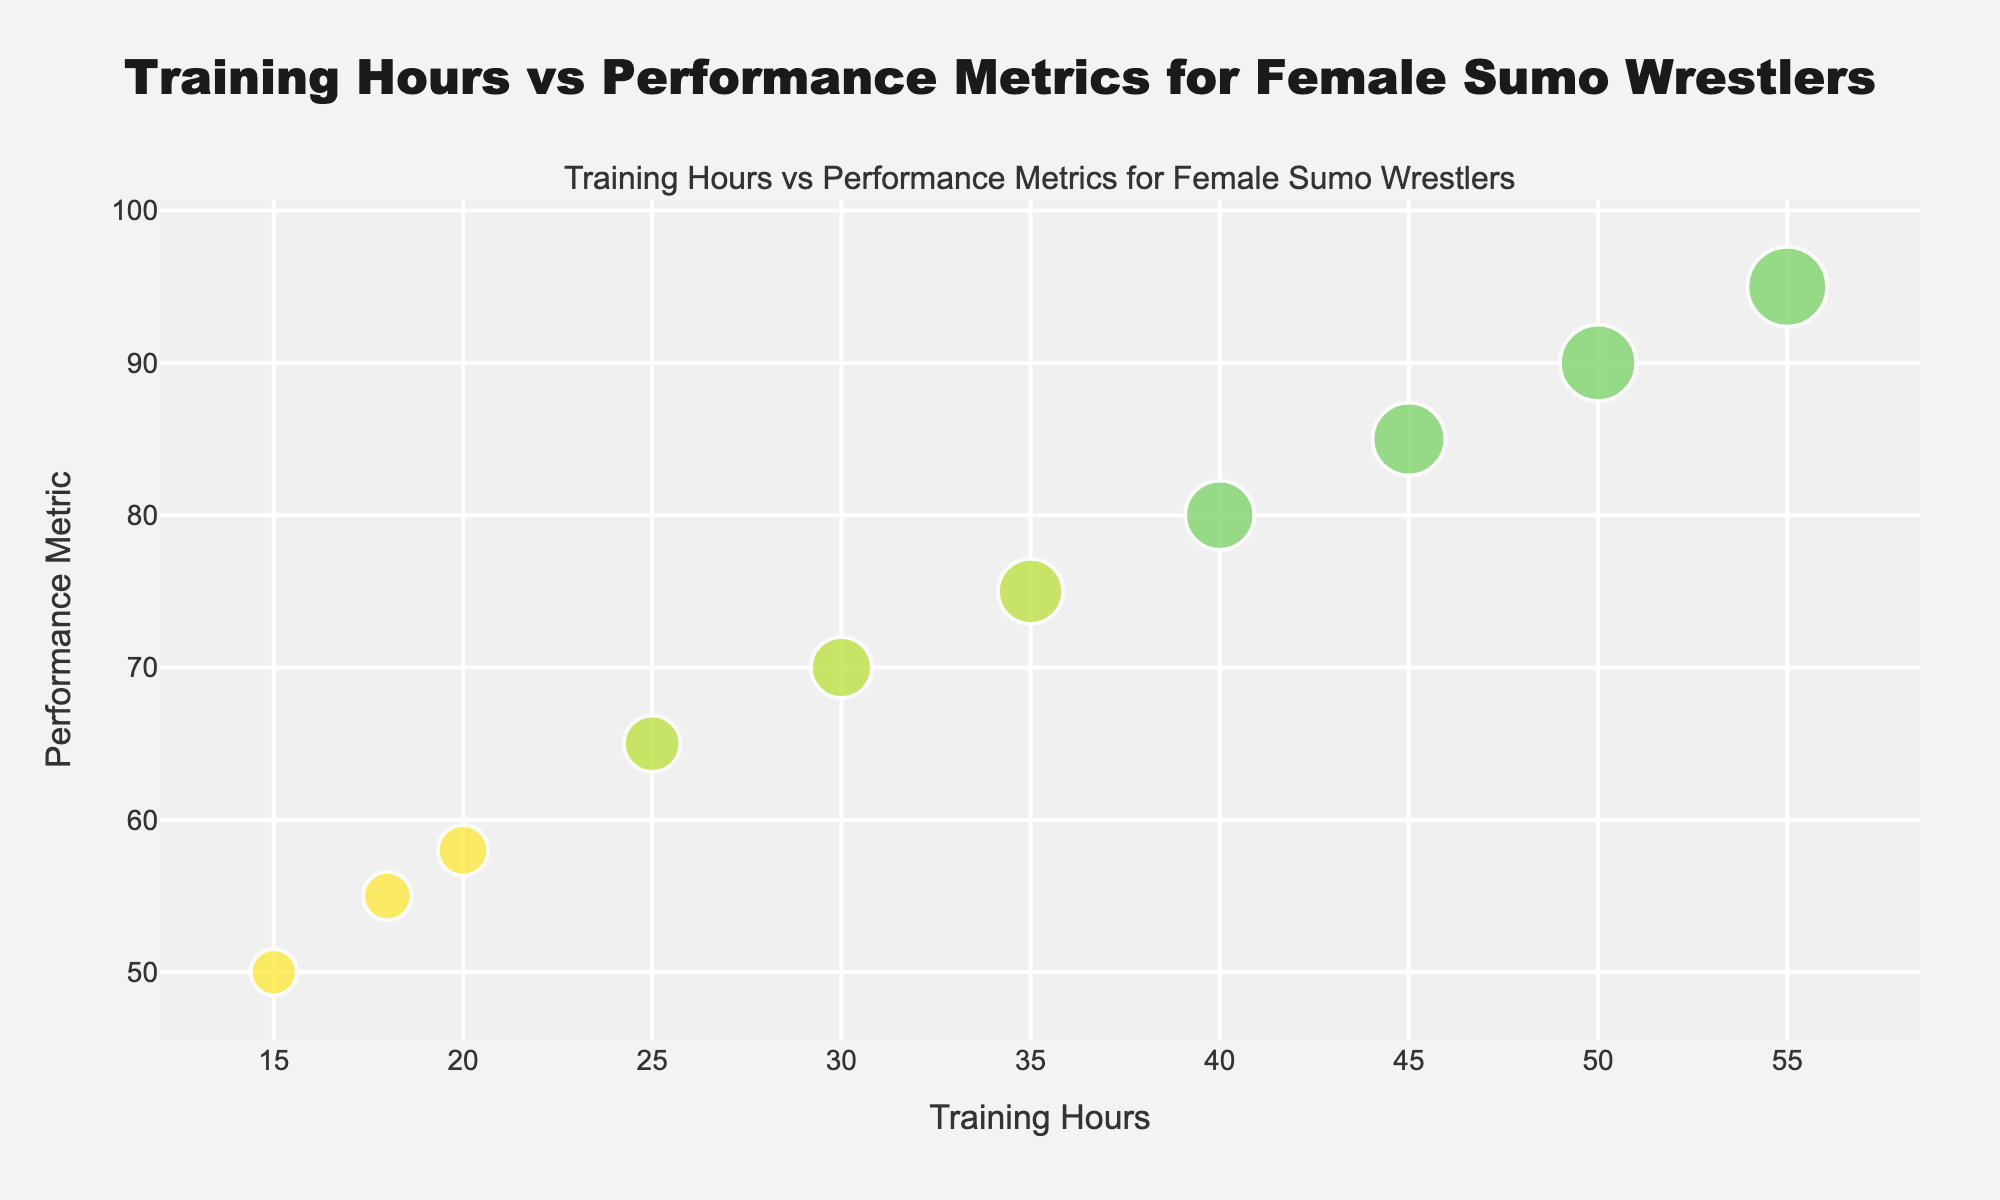What is the title of the figure? The title of the figure is displayed right at the top of the plot.
Answer: Training Hours vs Performance Metrics for Female Sumo Wrestlers What are the x-axis and y-axis labels? The x-axis and y-axis labels are located at the bottom (x-axis) and left (y-axis) sides of the plot respectively.
Answer: Training Hours (x-axis), Performance Metric (y-axis) How many data points are there in the plot? Upon visual inspection, we can count the bubbles in the figure.
Answer: 10 What does the color of the bubbles represent? The color of the bubbles is used to distinguish the experience levels of the female sumo wrestlers.
Answer: Experience Level Which wrestler has the highest performance metric? To find the wrestler with the highest performance metric, locate the highest point on the y-axis and check the corresponding wrestler's name displayed in the hover text.
Answer: Tomoko Who has the largest bubble size and what does it represent? The largest bubble indicates the highest bubble size value. The hover text and bubble size give us this information.
Answer: Tomoko (60) What is the average training hours of intermediate level wrestlers? Identify the data points for intermediate level wrestlers, sum their training hours, then divide by the number of intermediate wrestlers. (25+30+35)/3
Answer: 30 training hours Compare the performance metrics of Beginner and Advanced level wrestlers. What can you conclude? Compare the y-axis values of the bubbles labeled as Beginner and Advanced. Advanced level wrestlers show higher performance metrics than beginners.
Answer: Advanced wrestlers have higher performance metrics Which experience level has the most variation in training hours? Observe the spread of the bubbles horizontally (x-axis) within each experience level. Advanced level has bubbles spread from 40 to 55 hours.
Answer: Advanced level What is the relationship between training hours and performance metrics? Visualizing the trend from the scatter plot, as training hours increase, performance metrics tend to increase as well, indicating a positive correlation. More training hours generally lead to higher performance.
Answer: Positive correlation 